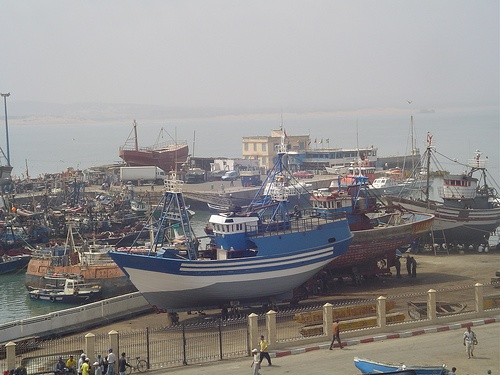Describe the objects in this image and their specific colors. I can see boat in lightgray, gray, darkgray, navy, and blue tones, boat in lightgray, gray, darkgray, and black tones, boat in lightgray, gray, black, and darkgray tones, boat in lightgray, gray, and darkgray tones, and boat in lightgray, gray, darkgray, and black tones in this image. 